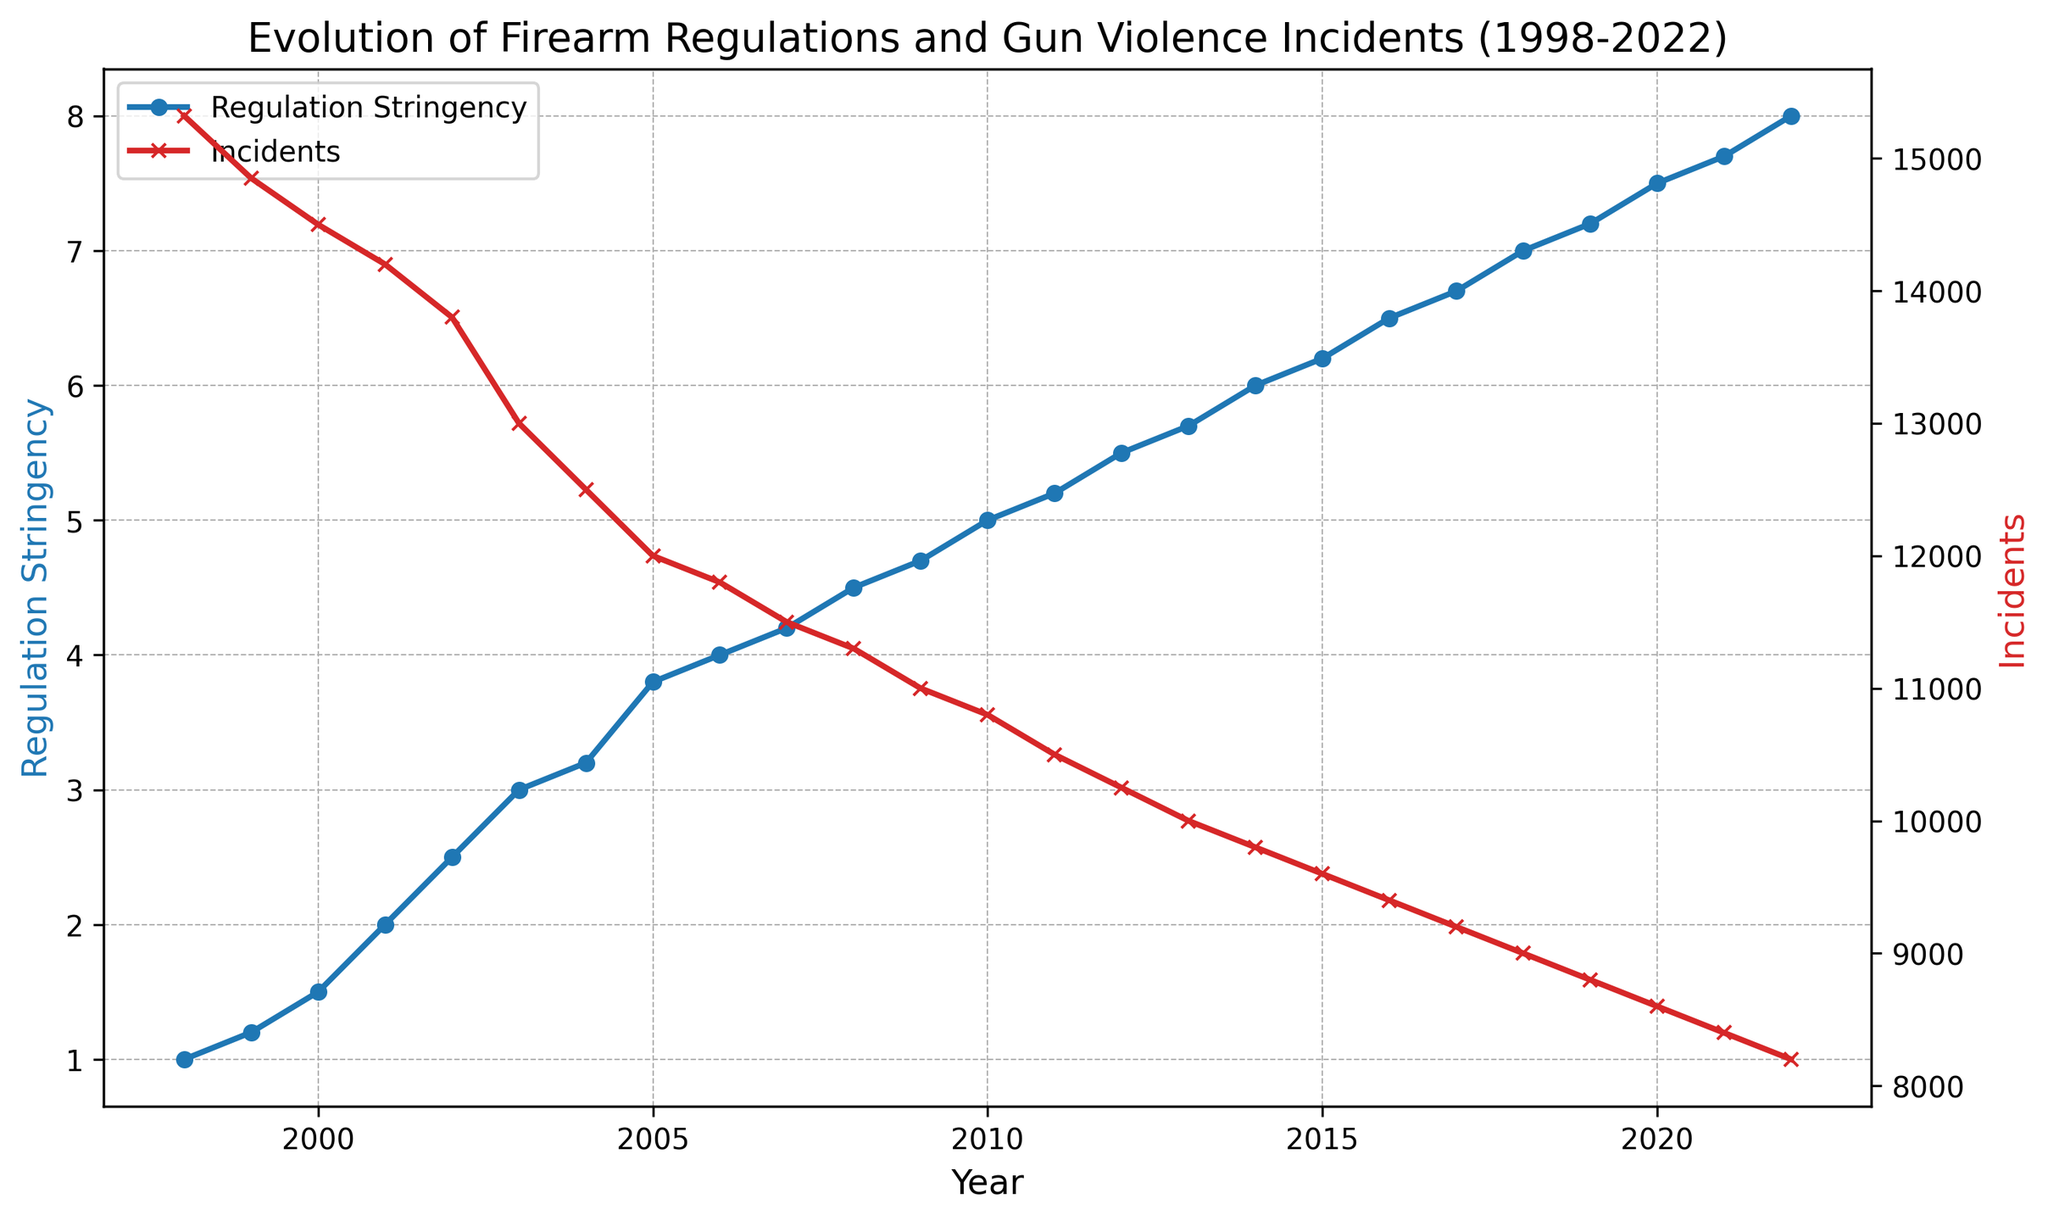What year saw the highest increase in regulation stringency? To find the year with the highest increase, we need to find the year-to-year difference in regulation stringency and identify the maximum. The highest increase is between 2002 and 2003, from 2.5 to 3 (0.5 increase)
Answer: 2002-2003 Which year had the lowest number of incidents? Observe the "Incidents" line on the graph and identify the lowest point. The year with the lowest incident count is 2022, with 8200 incidents
Answer: 2022 By how much did the incidents decrease between 1998 and 2022? Subtract the number of incidents in 2022 from that in 1998. The decrease is 15320 - 8200
Answer: 7120 In which years did regulation stringency remain constant? Identify periods where the "Regulation Stringency" line is flat with no change. Regulation stringency remained constant from 1998 to 1999 (1), and 2012 to 2013 (5.5)
Answer: 1998-1999, 2012-2013 Compare the regulation stringency in 2000 and 2010. Which year had higher stringency and by how much? Check the "Regulation Stringency" values for 2000 (1.5) and 2010 (5). The difference is 5 - 1.5
Answer: 2010 by 3.5 What is the average number of incidents over the first five years? Add the incident numbers from 1998 to 2002 and divide by 5: (15320 + 14850 + 14500 + 14200 + 13800) / 5 = 14934
Answer: 14934 Was there any year when both regulation stringency and incidents had the same numerical value? Compare the values for each year side-by-side. There is no year where both values are numerically equal
Answer: No Did incidents ever increase in any year, if so, which one? Check for any year where incident numbers are higher than the previous year. There are no such years; incidents decreased or remained constant
Answer: No How did the trend in incidents correlate visually with the trend in regulation stringency over time? Visually analyze the chart. Generally, as regulation stringency increased, the number of incidents decreased over the years, showing an inverse relationship
Answer: Inversely correlated What is the difference in incidents between the years with the highest and lowest regulation stringency? Subtract the number of incidents in 2022 (the highest stringency) from those in 1998 (the lowest stringency). The difference is 15320 - 8200
Answer: 7120 